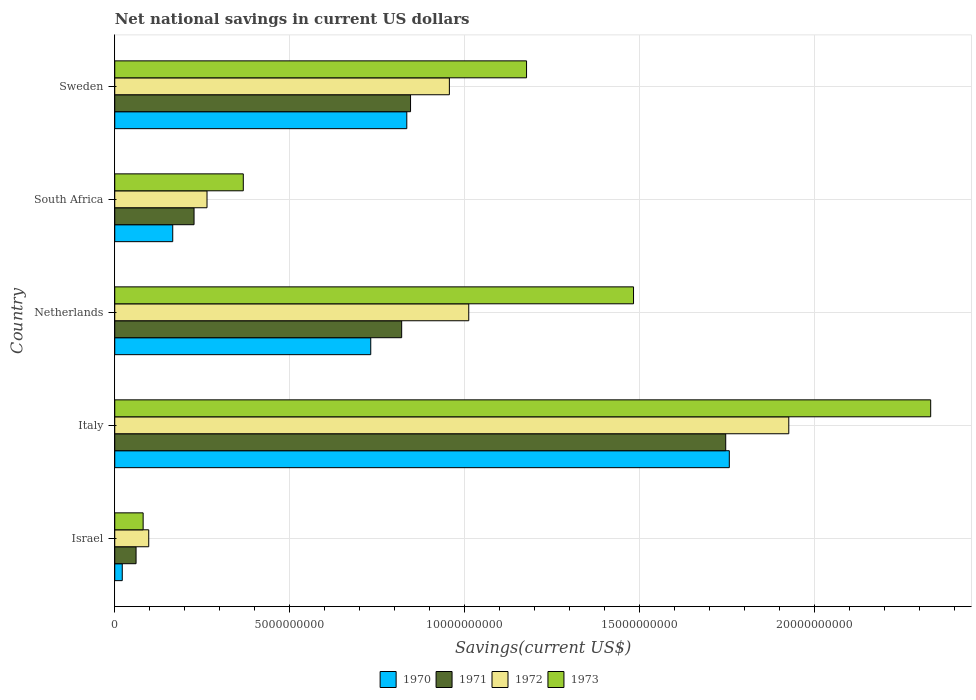How many different coloured bars are there?
Offer a very short reply. 4. Are the number of bars per tick equal to the number of legend labels?
Make the answer very short. Yes. How many bars are there on the 1st tick from the bottom?
Offer a very short reply. 4. In how many cases, is the number of bars for a given country not equal to the number of legend labels?
Give a very brief answer. 0. What is the net national savings in 1973 in Israel?
Provide a succinct answer. 8.11e+08. Across all countries, what is the maximum net national savings in 1970?
Your answer should be very brief. 1.76e+1. Across all countries, what is the minimum net national savings in 1972?
Make the answer very short. 9.71e+08. What is the total net national savings in 1971 in the graph?
Ensure brevity in your answer.  3.70e+1. What is the difference between the net national savings in 1970 in Israel and that in Italy?
Provide a succinct answer. -1.73e+1. What is the difference between the net national savings in 1970 in Italy and the net national savings in 1972 in Israel?
Your response must be concise. 1.66e+1. What is the average net national savings in 1973 per country?
Make the answer very short. 1.09e+1. What is the difference between the net national savings in 1973 and net national savings in 1972 in Italy?
Your response must be concise. 4.05e+09. In how many countries, is the net national savings in 1972 greater than 5000000000 US$?
Provide a succinct answer. 3. What is the ratio of the net national savings in 1972 in Israel to that in Sweden?
Offer a very short reply. 0.1. Is the difference between the net national savings in 1973 in Italy and Sweden greater than the difference between the net national savings in 1972 in Italy and Sweden?
Ensure brevity in your answer.  Yes. What is the difference between the highest and the second highest net national savings in 1973?
Your answer should be compact. 8.49e+09. What is the difference between the highest and the lowest net national savings in 1971?
Make the answer very short. 1.68e+1. In how many countries, is the net national savings in 1970 greater than the average net national savings in 1970 taken over all countries?
Give a very brief answer. 3. Is it the case that in every country, the sum of the net national savings in 1973 and net national savings in 1971 is greater than the net national savings in 1972?
Provide a short and direct response. Yes. How many bars are there?
Keep it short and to the point. 20. Are all the bars in the graph horizontal?
Keep it short and to the point. Yes. How many countries are there in the graph?
Provide a short and direct response. 5. What is the difference between two consecutive major ticks on the X-axis?
Your answer should be very brief. 5.00e+09. Does the graph contain any zero values?
Your answer should be very brief. No. Does the graph contain grids?
Make the answer very short. Yes. Where does the legend appear in the graph?
Offer a very short reply. Bottom center. What is the title of the graph?
Offer a terse response. Net national savings in current US dollars. What is the label or title of the X-axis?
Provide a succinct answer. Savings(current US$). What is the Savings(current US$) of 1970 in Israel?
Your answer should be very brief. 2.15e+08. What is the Savings(current US$) in 1971 in Israel?
Provide a short and direct response. 6.09e+08. What is the Savings(current US$) in 1972 in Israel?
Offer a terse response. 9.71e+08. What is the Savings(current US$) in 1973 in Israel?
Your answer should be very brief. 8.11e+08. What is the Savings(current US$) of 1970 in Italy?
Keep it short and to the point. 1.76e+1. What is the Savings(current US$) in 1971 in Italy?
Make the answer very short. 1.75e+1. What is the Savings(current US$) in 1972 in Italy?
Keep it short and to the point. 1.93e+1. What is the Savings(current US$) in 1973 in Italy?
Offer a terse response. 2.33e+1. What is the Savings(current US$) in 1970 in Netherlands?
Offer a very short reply. 7.31e+09. What is the Savings(current US$) of 1971 in Netherlands?
Ensure brevity in your answer.  8.20e+09. What is the Savings(current US$) of 1972 in Netherlands?
Your answer should be compact. 1.01e+1. What is the Savings(current US$) of 1973 in Netherlands?
Your response must be concise. 1.48e+1. What is the Savings(current US$) of 1970 in South Africa?
Give a very brief answer. 1.66e+09. What is the Savings(current US$) in 1971 in South Africa?
Keep it short and to the point. 2.27e+09. What is the Savings(current US$) of 1972 in South Africa?
Keep it short and to the point. 2.64e+09. What is the Savings(current US$) in 1973 in South Africa?
Your response must be concise. 3.67e+09. What is the Savings(current US$) in 1970 in Sweden?
Provide a succinct answer. 8.34e+09. What is the Savings(current US$) in 1971 in Sweden?
Your answer should be very brief. 8.45e+09. What is the Savings(current US$) of 1972 in Sweden?
Give a very brief answer. 9.56e+09. What is the Savings(current US$) of 1973 in Sweden?
Provide a short and direct response. 1.18e+1. Across all countries, what is the maximum Savings(current US$) in 1970?
Provide a short and direct response. 1.76e+1. Across all countries, what is the maximum Savings(current US$) of 1971?
Provide a short and direct response. 1.75e+1. Across all countries, what is the maximum Savings(current US$) of 1972?
Give a very brief answer. 1.93e+1. Across all countries, what is the maximum Savings(current US$) of 1973?
Keep it short and to the point. 2.33e+1. Across all countries, what is the minimum Savings(current US$) of 1970?
Your response must be concise. 2.15e+08. Across all countries, what is the minimum Savings(current US$) of 1971?
Offer a terse response. 6.09e+08. Across all countries, what is the minimum Savings(current US$) in 1972?
Ensure brevity in your answer.  9.71e+08. Across all countries, what is the minimum Savings(current US$) in 1973?
Offer a very short reply. 8.11e+08. What is the total Savings(current US$) in 1970 in the graph?
Your answer should be very brief. 3.51e+1. What is the total Savings(current US$) of 1971 in the graph?
Keep it short and to the point. 3.70e+1. What is the total Savings(current US$) in 1972 in the graph?
Ensure brevity in your answer.  4.25e+1. What is the total Savings(current US$) in 1973 in the graph?
Provide a short and direct response. 5.44e+1. What is the difference between the Savings(current US$) of 1970 in Israel and that in Italy?
Your response must be concise. -1.73e+1. What is the difference between the Savings(current US$) in 1971 in Israel and that in Italy?
Keep it short and to the point. -1.68e+1. What is the difference between the Savings(current US$) of 1972 in Israel and that in Italy?
Offer a terse response. -1.83e+1. What is the difference between the Savings(current US$) of 1973 in Israel and that in Italy?
Offer a terse response. -2.25e+1. What is the difference between the Savings(current US$) of 1970 in Israel and that in Netherlands?
Make the answer very short. -7.10e+09. What is the difference between the Savings(current US$) in 1971 in Israel and that in Netherlands?
Offer a terse response. -7.59e+09. What is the difference between the Savings(current US$) of 1972 in Israel and that in Netherlands?
Your answer should be compact. -9.14e+09. What is the difference between the Savings(current US$) of 1973 in Israel and that in Netherlands?
Your response must be concise. -1.40e+1. What is the difference between the Savings(current US$) of 1970 in Israel and that in South Africa?
Your answer should be very brief. -1.44e+09. What is the difference between the Savings(current US$) in 1971 in Israel and that in South Africa?
Give a very brief answer. -1.66e+09. What is the difference between the Savings(current US$) in 1972 in Israel and that in South Africa?
Offer a terse response. -1.66e+09. What is the difference between the Savings(current US$) of 1973 in Israel and that in South Africa?
Your answer should be very brief. -2.86e+09. What is the difference between the Savings(current US$) in 1970 in Israel and that in Sweden?
Provide a short and direct response. -8.13e+09. What is the difference between the Savings(current US$) of 1971 in Israel and that in Sweden?
Your answer should be very brief. -7.84e+09. What is the difference between the Savings(current US$) in 1972 in Israel and that in Sweden?
Keep it short and to the point. -8.59e+09. What is the difference between the Savings(current US$) of 1973 in Israel and that in Sweden?
Provide a short and direct response. -1.10e+1. What is the difference between the Savings(current US$) in 1970 in Italy and that in Netherlands?
Offer a terse response. 1.02e+1. What is the difference between the Savings(current US$) in 1971 in Italy and that in Netherlands?
Make the answer very short. 9.26e+09. What is the difference between the Savings(current US$) of 1972 in Italy and that in Netherlands?
Offer a terse response. 9.14e+09. What is the difference between the Savings(current US$) in 1973 in Italy and that in Netherlands?
Ensure brevity in your answer.  8.49e+09. What is the difference between the Savings(current US$) of 1970 in Italy and that in South Africa?
Your answer should be compact. 1.59e+1. What is the difference between the Savings(current US$) in 1971 in Italy and that in South Africa?
Your answer should be compact. 1.52e+1. What is the difference between the Savings(current US$) of 1972 in Italy and that in South Africa?
Provide a succinct answer. 1.66e+1. What is the difference between the Savings(current US$) of 1973 in Italy and that in South Africa?
Your response must be concise. 1.96e+1. What is the difference between the Savings(current US$) of 1970 in Italy and that in Sweden?
Ensure brevity in your answer.  9.21e+09. What is the difference between the Savings(current US$) of 1971 in Italy and that in Sweden?
Offer a very short reply. 9.00e+09. What is the difference between the Savings(current US$) of 1972 in Italy and that in Sweden?
Provide a succinct answer. 9.70e+09. What is the difference between the Savings(current US$) of 1973 in Italy and that in Sweden?
Ensure brevity in your answer.  1.15e+1. What is the difference between the Savings(current US$) in 1970 in Netherlands and that in South Africa?
Offer a terse response. 5.66e+09. What is the difference between the Savings(current US$) in 1971 in Netherlands and that in South Africa?
Your answer should be very brief. 5.93e+09. What is the difference between the Savings(current US$) in 1972 in Netherlands and that in South Africa?
Your response must be concise. 7.48e+09. What is the difference between the Savings(current US$) in 1973 in Netherlands and that in South Africa?
Make the answer very short. 1.11e+1. What is the difference between the Savings(current US$) in 1970 in Netherlands and that in Sweden?
Ensure brevity in your answer.  -1.03e+09. What is the difference between the Savings(current US$) in 1971 in Netherlands and that in Sweden?
Keep it short and to the point. -2.53e+08. What is the difference between the Savings(current US$) in 1972 in Netherlands and that in Sweden?
Your answer should be compact. 5.54e+08. What is the difference between the Savings(current US$) in 1973 in Netherlands and that in Sweden?
Your response must be concise. 3.06e+09. What is the difference between the Savings(current US$) in 1970 in South Africa and that in Sweden?
Ensure brevity in your answer.  -6.69e+09. What is the difference between the Savings(current US$) in 1971 in South Africa and that in Sweden?
Offer a terse response. -6.18e+09. What is the difference between the Savings(current US$) of 1972 in South Africa and that in Sweden?
Keep it short and to the point. -6.92e+09. What is the difference between the Savings(current US$) in 1973 in South Africa and that in Sweden?
Offer a very short reply. -8.09e+09. What is the difference between the Savings(current US$) of 1970 in Israel and the Savings(current US$) of 1971 in Italy?
Your answer should be very brief. -1.72e+1. What is the difference between the Savings(current US$) in 1970 in Israel and the Savings(current US$) in 1972 in Italy?
Provide a short and direct response. -1.90e+1. What is the difference between the Savings(current US$) of 1970 in Israel and the Savings(current US$) of 1973 in Italy?
Your answer should be compact. -2.31e+1. What is the difference between the Savings(current US$) of 1971 in Israel and the Savings(current US$) of 1972 in Italy?
Your answer should be very brief. -1.86e+1. What is the difference between the Savings(current US$) of 1971 in Israel and the Savings(current US$) of 1973 in Italy?
Make the answer very short. -2.27e+1. What is the difference between the Savings(current US$) in 1972 in Israel and the Savings(current US$) in 1973 in Italy?
Provide a succinct answer. -2.23e+1. What is the difference between the Savings(current US$) of 1970 in Israel and the Savings(current US$) of 1971 in Netherlands?
Give a very brief answer. -7.98e+09. What is the difference between the Savings(current US$) of 1970 in Israel and the Savings(current US$) of 1972 in Netherlands?
Make the answer very short. -9.90e+09. What is the difference between the Savings(current US$) of 1970 in Israel and the Savings(current US$) of 1973 in Netherlands?
Your answer should be very brief. -1.46e+1. What is the difference between the Savings(current US$) in 1971 in Israel and the Savings(current US$) in 1972 in Netherlands?
Give a very brief answer. -9.50e+09. What is the difference between the Savings(current US$) in 1971 in Israel and the Savings(current US$) in 1973 in Netherlands?
Give a very brief answer. -1.42e+1. What is the difference between the Savings(current US$) in 1972 in Israel and the Savings(current US$) in 1973 in Netherlands?
Make the answer very short. -1.38e+1. What is the difference between the Savings(current US$) in 1970 in Israel and the Savings(current US$) in 1971 in South Africa?
Make the answer very short. -2.05e+09. What is the difference between the Savings(current US$) of 1970 in Israel and the Savings(current US$) of 1972 in South Africa?
Offer a terse response. -2.42e+09. What is the difference between the Savings(current US$) in 1970 in Israel and the Savings(current US$) in 1973 in South Africa?
Your answer should be very brief. -3.46e+09. What is the difference between the Savings(current US$) of 1971 in Israel and the Savings(current US$) of 1972 in South Africa?
Give a very brief answer. -2.03e+09. What is the difference between the Savings(current US$) of 1971 in Israel and the Savings(current US$) of 1973 in South Africa?
Provide a succinct answer. -3.06e+09. What is the difference between the Savings(current US$) in 1972 in Israel and the Savings(current US$) in 1973 in South Africa?
Your response must be concise. -2.70e+09. What is the difference between the Savings(current US$) in 1970 in Israel and the Savings(current US$) in 1971 in Sweden?
Give a very brief answer. -8.23e+09. What is the difference between the Savings(current US$) in 1970 in Israel and the Savings(current US$) in 1972 in Sweden?
Give a very brief answer. -9.34e+09. What is the difference between the Savings(current US$) of 1970 in Israel and the Savings(current US$) of 1973 in Sweden?
Your answer should be compact. -1.15e+1. What is the difference between the Savings(current US$) in 1971 in Israel and the Savings(current US$) in 1972 in Sweden?
Provide a succinct answer. -8.95e+09. What is the difference between the Savings(current US$) of 1971 in Israel and the Savings(current US$) of 1973 in Sweden?
Your response must be concise. -1.12e+1. What is the difference between the Savings(current US$) in 1972 in Israel and the Savings(current US$) in 1973 in Sweden?
Keep it short and to the point. -1.08e+1. What is the difference between the Savings(current US$) in 1970 in Italy and the Savings(current US$) in 1971 in Netherlands?
Offer a terse response. 9.36e+09. What is the difference between the Savings(current US$) of 1970 in Italy and the Savings(current US$) of 1972 in Netherlands?
Make the answer very short. 7.44e+09. What is the difference between the Savings(current US$) in 1970 in Italy and the Savings(current US$) in 1973 in Netherlands?
Offer a very short reply. 2.74e+09. What is the difference between the Savings(current US$) in 1971 in Italy and the Savings(current US$) in 1972 in Netherlands?
Give a very brief answer. 7.34e+09. What is the difference between the Savings(current US$) in 1971 in Italy and the Savings(current US$) in 1973 in Netherlands?
Make the answer very short. 2.63e+09. What is the difference between the Savings(current US$) in 1972 in Italy and the Savings(current US$) in 1973 in Netherlands?
Your answer should be compact. 4.44e+09. What is the difference between the Savings(current US$) in 1970 in Italy and the Savings(current US$) in 1971 in South Africa?
Provide a short and direct response. 1.53e+1. What is the difference between the Savings(current US$) in 1970 in Italy and the Savings(current US$) in 1972 in South Africa?
Provide a succinct answer. 1.49e+1. What is the difference between the Savings(current US$) of 1970 in Italy and the Savings(current US$) of 1973 in South Africa?
Your answer should be very brief. 1.39e+1. What is the difference between the Savings(current US$) in 1971 in Italy and the Savings(current US$) in 1972 in South Africa?
Offer a very short reply. 1.48e+1. What is the difference between the Savings(current US$) of 1971 in Italy and the Savings(current US$) of 1973 in South Africa?
Your answer should be very brief. 1.38e+1. What is the difference between the Savings(current US$) of 1972 in Italy and the Savings(current US$) of 1973 in South Africa?
Provide a short and direct response. 1.56e+1. What is the difference between the Savings(current US$) in 1970 in Italy and the Savings(current US$) in 1971 in Sweden?
Give a very brief answer. 9.11e+09. What is the difference between the Savings(current US$) in 1970 in Italy and the Savings(current US$) in 1972 in Sweden?
Offer a very short reply. 8.00e+09. What is the difference between the Savings(current US$) of 1970 in Italy and the Savings(current US$) of 1973 in Sweden?
Provide a succinct answer. 5.79e+09. What is the difference between the Savings(current US$) in 1971 in Italy and the Savings(current US$) in 1972 in Sweden?
Provide a succinct answer. 7.89e+09. What is the difference between the Savings(current US$) in 1971 in Italy and the Savings(current US$) in 1973 in Sweden?
Provide a succinct answer. 5.69e+09. What is the difference between the Savings(current US$) in 1972 in Italy and the Savings(current US$) in 1973 in Sweden?
Offer a terse response. 7.49e+09. What is the difference between the Savings(current US$) in 1970 in Netherlands and the Savings(current US$) in 1971 in South Africa?
Your response must be concise. 5.05e+09. What is the difference between the Savings(current US$) of 1970 in Netherlands and the Savings(current US$) of 1972 in South Africa?
Your response must be concise. 4.68e+09. What is the difference between the Savings(current US$) in 1970 in Netherlands and the Savings(current US$) in 1973 in South Africa?
Provide a short and direct response. 3.64e+09. What is the difference between the Savings(current US$) of 1971 in Netherlands and the Savings(current US$) of 1972 in South Africa?
Offer a very short reply. 5.56e+09. What is the difference between the Savings(current US$) in 1971 in Netherlands and the Savings(current US$) in 1973 in South Africa?
Keep it short and to the point. 4.52e+09. What is the difference between the Savings(current US$) in 1972 in Netherlands and the Savings(current US$) in 1973 in South Africa?
Make the answer very short. 6.44e+09. What is the difference between the Savings(current US$) in 1970 in Netherlands and the Savings(current US$) in 1971 in Sweden?
Your answer should be very brief. -1.14e+09. What is the difference between the Savings(current US$) of 1970 in Netherlands and the Savings(current US$) of 1972 in Sweden?
Offer a very short reply. -2.25e+09. What is the difference between the Savings(current US$) of 1970 in Netherlands and the Savings(current US$) of 1973 in Sweden?
Offer a terse response. -4.45e+09. What is the difference between the Savings(current US$) of 1971 in Netherlands and the Savings(current US$) of 1972 in Sweden?
Your answer should be very brief. -1.36e+09. What is the difference between the Savings(current US$) in 1971 in Netherlands and the Savings(current US$) in 1973 in Sweden?
Your response must be concise. -3.57e+09. What is the difference between the Savings(current US$) in 1972 in Netherlands and the Savings(current US$) in 1973 in Sweden?
Ensure brevity in your answer.  -1.65e+09. What is the difference between the Savings(current US$) of 1970 in South Africa and the Savings(current US$) of 1971 in Sweden?
Your response must be concise. -6.79e+09. What is the difference between the Savings(current US$) of 1970 in South Africa and the Savings(current US$) of 1972 in Sweden?
Ensure brevity in your answer.  -7.90e+09. What is the difference between the Savings(current US$) in 1970 in South Africa and the Savings(current US$) in 1973 in Sweden?
Provide a succinct answer. -1.01e+1. What is the difference between the Savings(current US$) in 1971 in South Africa and the Savings(current US$) in 1972 in Sweden?
Offer a very short reply. -7.29e+09. What is the difference between the Savings(current US$) of 1971 in South Africa and the Savings(current US$) of 1973 in Sweden?
Offer a very short reply. -9.50e+09. What is the difference between the Savings(current US$) in 1972 in South Africa and the Savings(current US$) in 1973 in Sweden?
Offer a terse response. -9.13e+09. What is the average Savings(current US$) in 1970 per country?
Offer a terse response. 7.02e+09. What is the average Savings(current US$) of 1971 per country?
Keep it short and to the point. 7.39e+09. What is the average Savings(current US$) of 1972 per country?
Offer a very short reply. 8.51e+09. What is the average Savings(current US$) of 1973 per country?
Your response must be concise. 1.09e+1. What is the difference between the Savings(current US$) of 1970 and Savings(current US$) of 1971 in Israel?
Provide a succinct answer. -3.94e+08. What is the difference between the Savings(current US$) in 1970 and Savings(current US$) in 1972 in Israel?
Keep it short and to the point. -7.56e+08. What is the difference between the Savings(current US$) in 1970 and Savings(current US$) in 1973 in Israel?
Your answer should be very brief. -5.96e+08. What is the difference between the Savings(current US$) in 1971 and Savings(current US$) in 1972 in Israel?
Keep it short and to the point. -3.62e+08. What is the difference between the Savings(current US$) of 1971 and Savings(current US$) of 1973 in Israel?
Your response must be concise. -2.02e+08. What is the difference between the Savings(current US$) of 1972 and Savings(current US$) of 1973 in Israel?
Make the answer very short. 1.60e+08. What is the difference between the Savings(current US$) of 1970 and Savings(current US$) of 1971 in Italy?
Your response must be concise. 1.03e+08. What is the difference between the Savings(current US$) in 1970 and Savings(current US$) in 1972 in Italy?
Your answer should be compact. -1.70e+09. What is the difference between the Savings(current US$) of 1970 and Savings(current US$) of 1973 in Italy?
Provide a short and direct response. -5.75e+09. What is the difference between the Savings(current US$) in 1971 and Savings(current US$) in 1972 in Italy?
Your answer should be compact. -1.80e+09. What is the difference between the Savings(current US$) of 1971 and Savings(current US$) of 1973 in Italy?
Ensure brevity in your answer.  -5.86e+09. What is the difference between the Savings(current US$) in 1972 and Savings(current US$) in 1973 in Italy?
Provide a succinct answer. -4.05e+09. What is the difference between the Savings(current US$) in 1970 and Savings(current US$) in 1971 in Netherlands?
Provide a succinct answer. -8.83e+08. What is the difference between the Savings(current US$) of 1970 and Savings(current US$) of 1972 in Netherlands?
Offer a very short reply. -2.80e+09. What is the difference between the Savings(current US$) of 1970 and Savings(current US$) of 1973 in Netherlands?
Provide a short and direct response. -7.51e+09. What is the difference between the Savings(current US$) of 1971 and Savings(current US$) of 1972 in Netherlands?
Provide a short and direct response. -1.92e+09. What is the difference between the Savings(current US$) in 1971 and Savings(current US$) in 1973 in Netherlands?
Offer a terse response. -6.62e+09. What is the difference between the Savings(current US$) of 1972 and Savings(current US$) of 1973 in Netherlands?
Your answer should be very brief. -4.71e+09. What is the difference between the Savings(current US$) of 1970 and Savings(current US$) of 1971 in South Africa?
Provide a succinct answer. -6.09e+08. What is the difference between the Savings(current US$) of 1970 and Savings(current US$) of 1972 in South Africa?
Your answer should be compact. -9.79e+08. What is the difference between the Savings(current US$) of 1970 and Savings(current US$) of 1973 in South Africa?
Provide a short and direct response. -2.02e+09. What is the difference between the Savings(current US$) of 1971 and Savings(current US$) of 1972 in South Africa?
Your answer should be compact. -3.70e+08. What is the difference between the Savings(current US$) of 1971 and Savings(current US$) of 1973 in South Africa?
Ensure brevity in your answer.  -1.41e+09. What is the difference between the Savings(current US$) of 1972 and Savings(current US$) of 1973 in South Africa?
Give a very brief answer. -1.04e+09. What is the difference between the Savings(current US$) of 1970 and Savings(current US$) of 1971 in Sweden?
Your response must be concise. -1.07e+08. What is the difference between the Savings(current US$) of 1970 and Savings(current US$) of 1972 in Sweden?
Provide a short and direct response. -1.22e+09. What is the difference between the Savings(current US$) in 1970 and Savings(current US$) in 1973 in Sweden?
Offer a very short reply. -3.42e+09. What is the difference between the Savings(current US$) in 1971 and Savings(current US$) in 1972 in Sweden?
Keep it short and to the point. -1.11e+09. What is the difference between the Savings(current US$) of 1971 and Savings(current US$) of 1973 in Sweden?
Provide a succinct answer. -3.31e+09. What is the difference between the Savings(current US$) in 1972 and Savings(current US$) in 1973 in Sweden?
Offer a very short reply. -2.20e+09. What is the ratio of the Savings(current US$) of 1970 in Israel to that in Italy?
Ensure brevity in your answer.  0.01. What is the ratio of the Savings(current US$) of 1971 in Israel to that in Italy?
Keep it short and to the point. 0.03. What is the ratio of the Savings(current US$) of 1972 in Israel to that in Italy?
Your answer should be very brief. 0.05. What is the ratio of the Savings(current US$) of 1973 in Israel to that in Italy?
Your answer should be compact. 0.03. What is the ratio of the Savings(current US$) in 1970 in Israel to that in Netherlands?
Make the answer very short. 0.03. What is the ratio of the Savings(current US$) in 1971 in Israel to that in Netherlands?
Provide a succinct answer. 0.07. What is the ratio of the Savings(current US$) in 1972 in Israel to that in Netherlands?
Ensure brevity in your answer.  0.1. What is the ratio of the Savings(current US$) of 1973 in Israel to that in Netherlands?
Ensure brevity in your answer.  0.05. What is the ratio of the Savings(current US$) in 1970 in Israel to that in South Africa?
Offer a very short reply. 0.13. What is the ratio of the Savings(current US$) in 1971 in Israel to that in South Africa?
Provide a short and direct response. 0.27. What is the ratio of the Savings(current US$) of 1972 in Israel to that in South Africa?
Your answer should be compact. 0.37. What is the ratio of the Savings(current US$) in 1973 in Israel to that in South Africa?
Your answer should be compact. 0.22. What is the ratio of the Savings(current US$) in 1970 in Israel to that in Sweden?
Offer a terse response. 0.03. What is the ratio of the Savings(current US$) in 1971 in Israel to that in Sweden?
Keep it short and to the point. 0.07. What is the ratio of the Savings(current US$) of 1972 in Israel to that in Sweden?
Give a very brief answer. 0.1. What is the ratio of the Savings(current US$) in 1973 in Israel to that in Sweden?
Ensure brevity in your answer.  0.07. What is the ratio of the Savings(current US$) in 1970 in Italy to that in Netherlands?
Give a very brief answer. 2.4. What is the ratio of the Savings(current US$) in 1971 in Italy to that in Netherlands?
Provide a short and direct response. 2.13. What is the ratio of the Savings(current US$) of 1972 in Italy to that in Netherlands?
Your answer should be compact. 1.9. What is the ratio of the Savings(current US$) in 1973 in Italy to that in Netherlands?
Your response must be concise. 1.57. What is the ratio of the Savings(current US$) of 1970 in Italy to that in South Africa?
Offer a very short reply. 10.6. What is the ratio of the Savings(current US$) of 1971 in Italy to that in South Africa?
Give a very brief answer. 7.7. What is the ratio of the Savings(current US$) in 1972 in Italy to that in South Africa?
Provide a short and direct response. 7.31. What is the ratio of the Savings(current US$) of 1973 in Italy to that in South Africa?
Offer a terse response. 6.35. What is the ratio of the Savings(current US$) in 1970 in Italy to that in Sweden?
Offer a terse response. 2.1. What is the ratio of the Savings(current US$) in 1971 in Italy to that in Sweden?
Ensure brevity in your answer.  2.07. What is the ratio of the Savings(current US$) in 1972 in Italy to that in Sweden?
Offer a very short reply. 2.01. What is the ratio of the Savings(current US$) in 1973 in Italy to that in Sweden?
Ensure brevity in your answer.  1.98. What is the ratio of the Savings(current US$) in 1970 in Netherlands to that in South Africa?
Ensure brevity in your answer.  4.42. What is the ratio of the Savings(current US$) of 1971 in Netherlands to that in South Africa?
Your response must be concise. 3.62. What is the ratio of the Savings(current US$) of 1972 in Netherlands to that in South Africa?
Your response must be concise. 3.84. What is the ratio of the Savings(current US$) of 1973 in Netherlands to that in South Africa?
Your response must be concise. 4.04. What is the ratio of the Savings(current US$) in 1970 in Netherlands to that in Sweden?
Your answer should be very brief. 0.88. What is the ratio of the Savings(current US$) in 1972 in Netherlands to that in Sweden?
Your response must be concise. 1.06. What is the ratio of the Savings(current US$) in 1973 in Netherlands to that in Sweden?
Offer a terse response. 1.26. What is the ratio of the Savings(current US$) in 1970 in South Africa to that in Sweden?
Offer a terse response. 0.2. What is the ratio of the Savings(current US$) of 1971 in South Africa to that in Sweden?
Ensure brevity in your answer.  0.27. What is the ratio of the Savings(current US$) in 1972 in South Africa to that in Sweden?
Offer a terse response. 0.28. What is the ratio of the Savings(current US$) in 1973 in South Africa to that in Sweden?
Offer a very short reply. 0.31. What is the difference between the highest and the second highest Savings(current US$) of 1970?
Offer a terse response. 9.21e+09. What is the difference between the highest and the second highest Savings(current US$) of 1971?
Keep it short and to the point. 9.00e+09. What is the difference between the highest and the second highest Savings(current US$) in 1972?
Your answer should be very brief. 9.14e+09. What is the difference between the highest and the second highest Savings(current US$) in 1973?
Keep it short and to the point. 8.49e+09. What is the difference between the highest and the lowest Savings(current US$) of 1970?
Make the answer very short. 1.73e+1. What is the difference between the highest and the lowest Savings(current US$) in 1971?
Keep it short and to the point. 1.68e+1. What is the difference between the highest and the lowest Savings(current US$) in 1972?
Provide a succinct answer. 1.83e+1. What is the difference between the highest and the lowest Savings(current US$) of 1973?
Ensure brevity in your answer.  2.25e+1. 